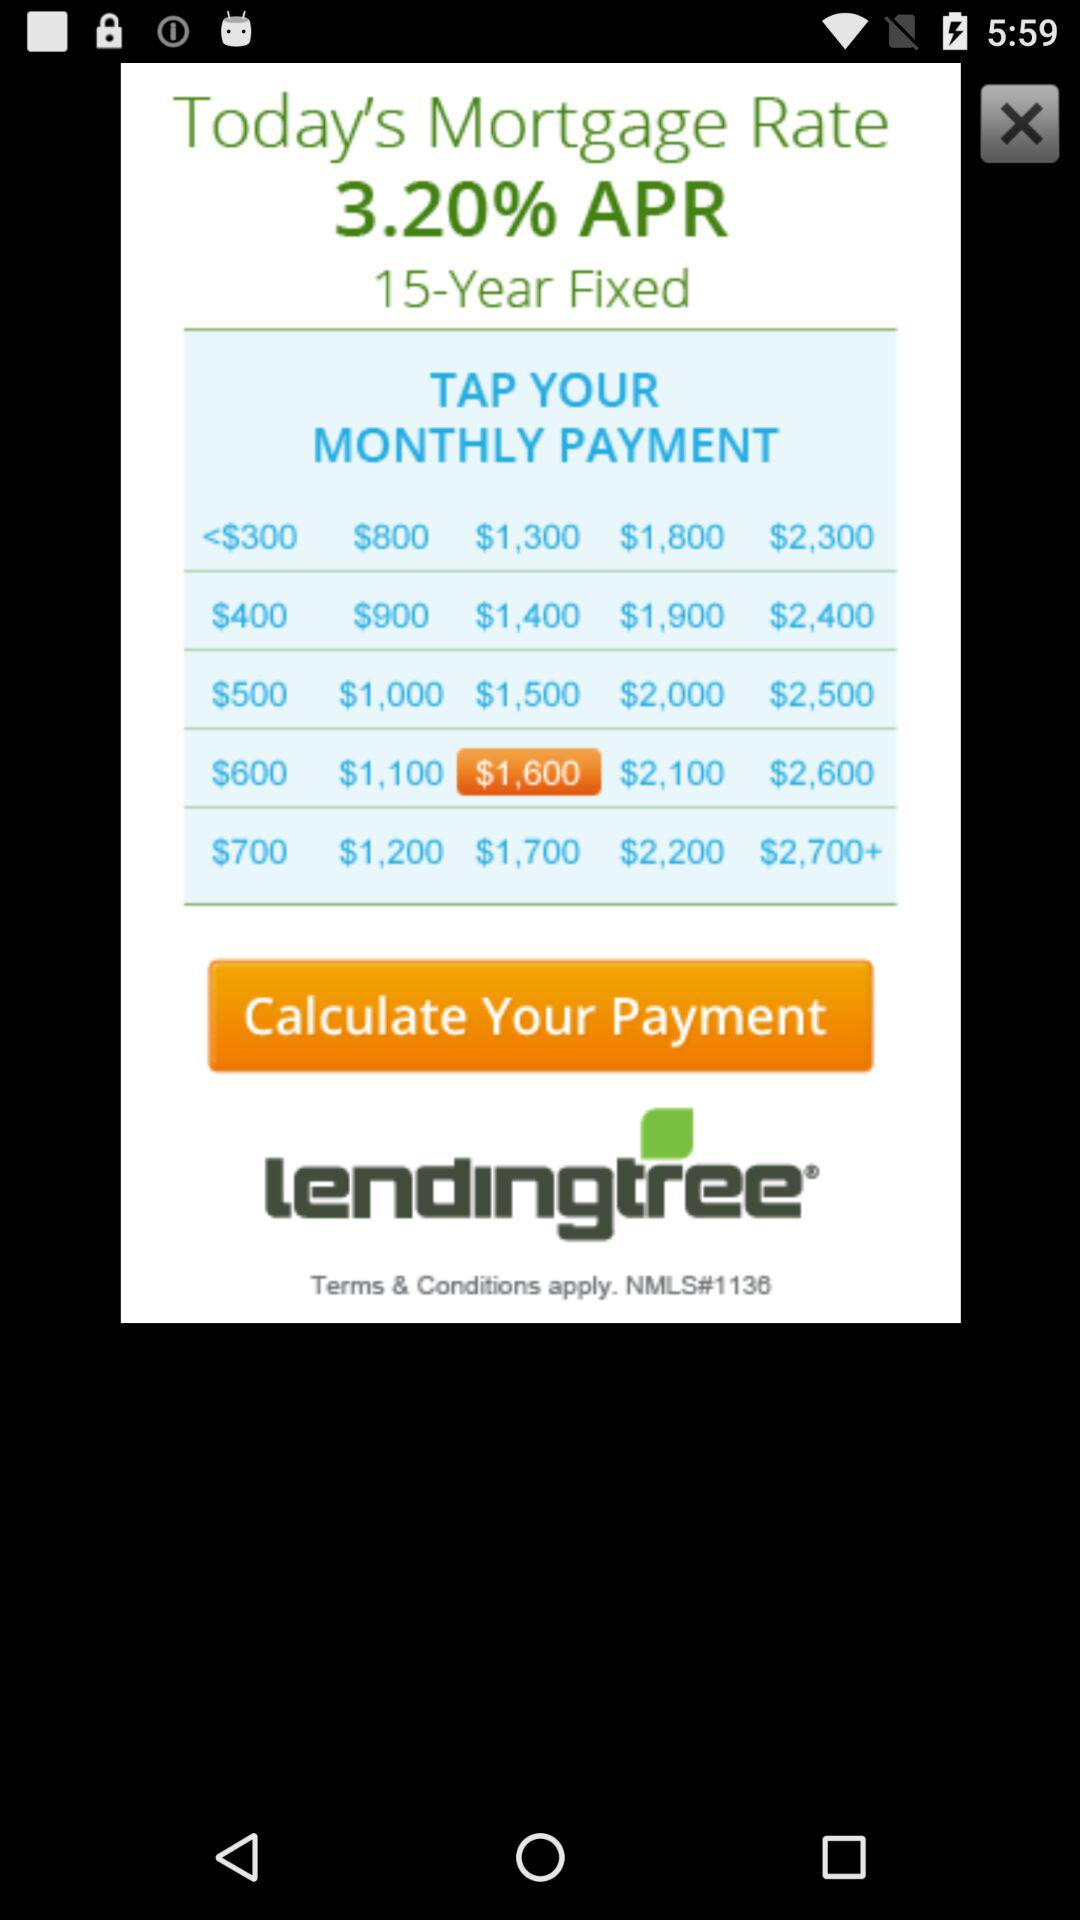What is the selected monthly payment? The selected monthly payment is $1,600. 